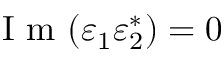<formula> <loc_0><loc_0><loc_500><loc_500>I m ( \varepsilon _ { 1 } \varepsilon _ { 2 } ^ { * } ) = 0</formula> 